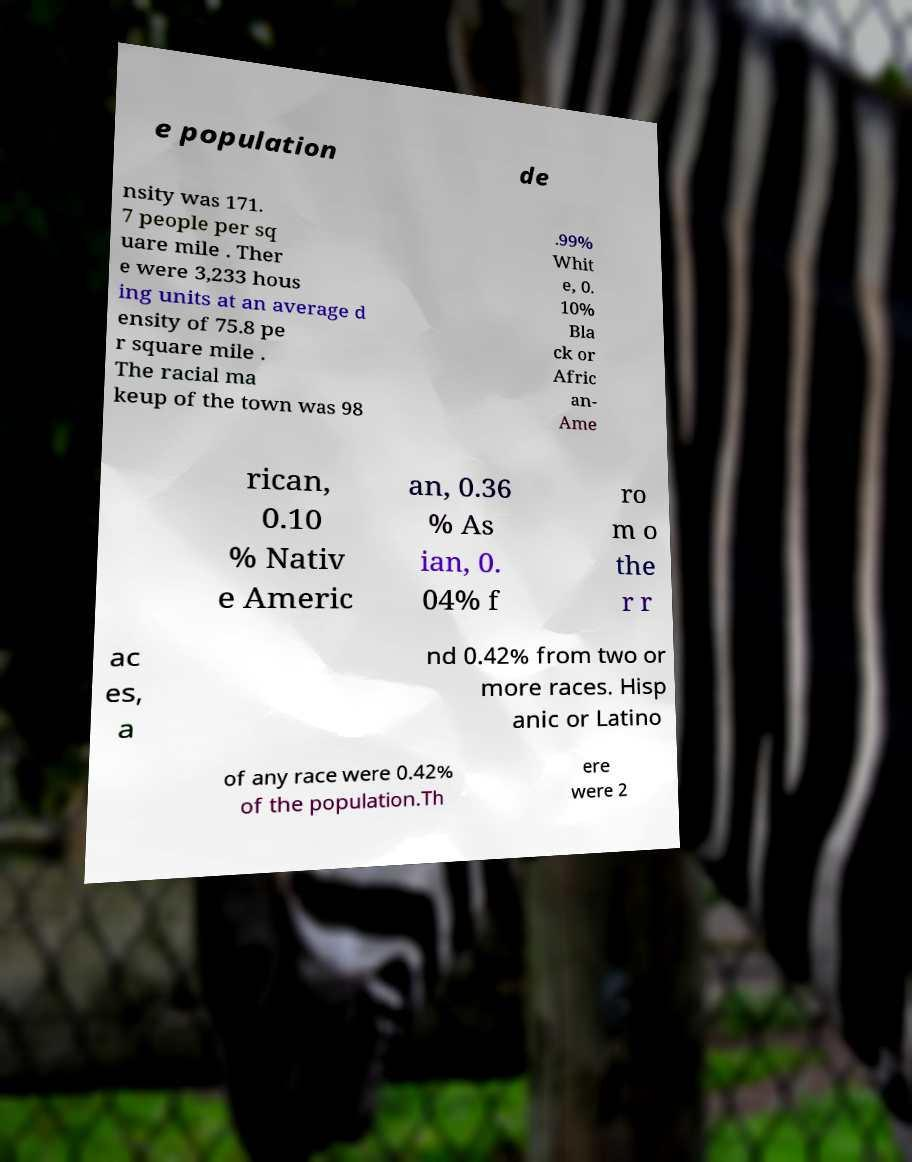Please identify and transcribe the text found in this image. e population de nsity was 171. 7 people per sq uare mile . Ther e were 3,233 hous ing units at an average d ensity of 75.8 pe r square mile . The racial ma keup of the town was 98 .99% Whit e, 0. 10% Bla ck or Afric an- Ame rican, 0.10 % Nativ e Americ an, 0.36 % As ian, 0. 04% f ro m o the r r ac es, a nd 0.42% from two or more races. Hisp anic or Latino of any race were 0.42% of the population.Th ere were 2 